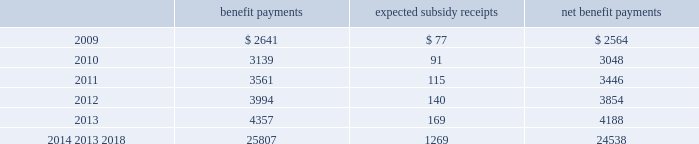Mastercard incorporated notes to consolidated financial statements 2014 ( continued ) ( in thousands , except percent and per share data ) the company does not make any contributions to its postretirement plan other than funding benefits payments .
The table summarizes expected net benefit payments from the company 2019s general assets through 2018 : benefit payments expected subsidy receipts benefit payments .
The company provides limited postemployment benefits to eligible former u.s .
Employees , primarily severance under a formal severance plan ( the 201cseverance plan 201d ) .
The company accounts for severance expense in accordance with sfas no .
112 , 201cemployers 2019 accounting for postemployment benefits 201d by accruing the expected cost of the severance benefits expected to be provided to former employees after employment over their relevant service periods .
The company updates the assumptions in determining the severance accrual by evaluating the actual severance activity and long-term trends underlying the assumptions .
As a result of updating the assumptions , the company recorded severance expense ( benefit ) related to the severance plan of $ 2643 , $ ( 3418 ) and $ 8400 , respectively , during the years 2008 , 2007 and 2006 .
The company has an accrued liability related to the severance plan and other severance obligations in the amount of $ 63863 and $ 56172 at december 31 , 2008 and 2007 , respectively .
Note 13 .
Debt on april 28 , 2008 , the company extended its committed unsecured revolving credit facility , dated as of april 28 , 2006 ( the 201ccredit facility 201d ) , for an additional year .
The new expiration date of the credit facility is april 26 , 2011 .
The available funding under the credit facility will remain at $ 2500000 through april 27 , 2010 and then decrease to $ 2000000 during the final year of the credit facility agreement .
Other terms and conditions in the credit facility remain unchanged .
The company 2019s option to request that each lender under the credit facility extend its commitment was provided pursuant to the original terms of the credit facility agreement .
Borrowings under the facility are available to provide liquidity in the event of one or more settlement failures by mastercard international customers and , subject to a limit of $ 500000 , for general corporate purposes .
A facility fee of 8 basis points on the total commitment , or approximately $ 2030 , is paid annually .
Interest on borrowings under the credit facility would be charged at the london interbank offered rate ( libor ) plus an applicable margin of 37 basis points or an alternative base rate , and a utilization fee of 10 basis points would be charged if outstanding borrowings under the facility exceed 50% ( 50 % ) of commitments .
The facility fee and borrowing cost are contingent upon the company 2019s credit rating .
The company also agreed to pay upfront fees of $ 1250 and administrative fees of $ 325 for the credit facility which are being amortized straight- line over three years .
Facility and other fees associated with the credit facility or prior facilities totaled $ 2353 , $ 2477 and $ 2717 for each of the years ended december 31 , 2008 , 2007 and 2006 , respectively .
Mastercard was in compliance with the covenants of the credit facility and had no borrowings under the credit facility at december 31 , 2008 or december 31 , 2007 .
The majority of credit facility lenders are customers or affiliates of customers of mastercard international .
In june 1998 , mastercard international issued ten-year unsecured , subordinated notes ( the 201cnotes 201d ) paying a fixed interest rate of 6.67% ( 6.67 % ) per annum .
Mastercard repaid the entire principal amount of $ 80000 on june 30 .
What was the ratio of the accrued liability accrued liability related to the severance plan in 2008 to 2007? 
Rationale: the ratio of the accrued liability related to the severance plan in 2008 to 2007 was 1.14 to 1
Computations: (63863 / 56172)
Answer: 1.13692. 